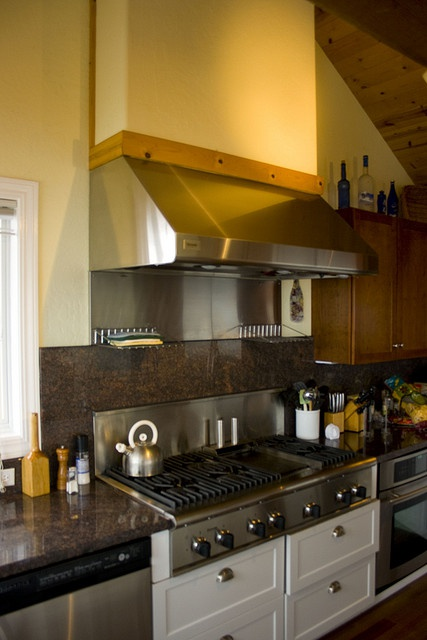Describe the objects in this image and their specific colors. I can see oven in olive, black, and gray tones, oven in olive, black, and gray tones, bottle in olive, black, gray, darkgray, and lightgray tones, cup in olive, lightgray, and darkgray tones, and bottle in olive, black, and gray tones in this image. 